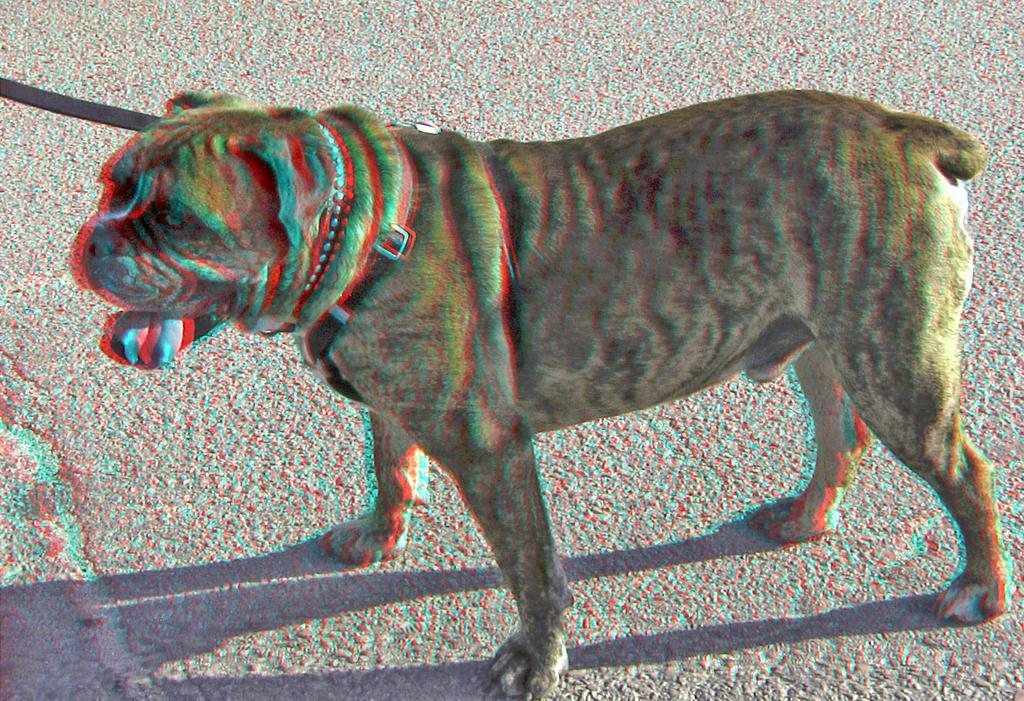What type of animal is in the image? There is a Shar Pei in the image. Where is the Shar Pei located in the image? The Shar Pei is present on the ground. What is around the Shar Pei's neck? There is a belt around the Shar Pei's neck. What type of powder is visible on the cushion in the image? There is no cushion present in the image. 